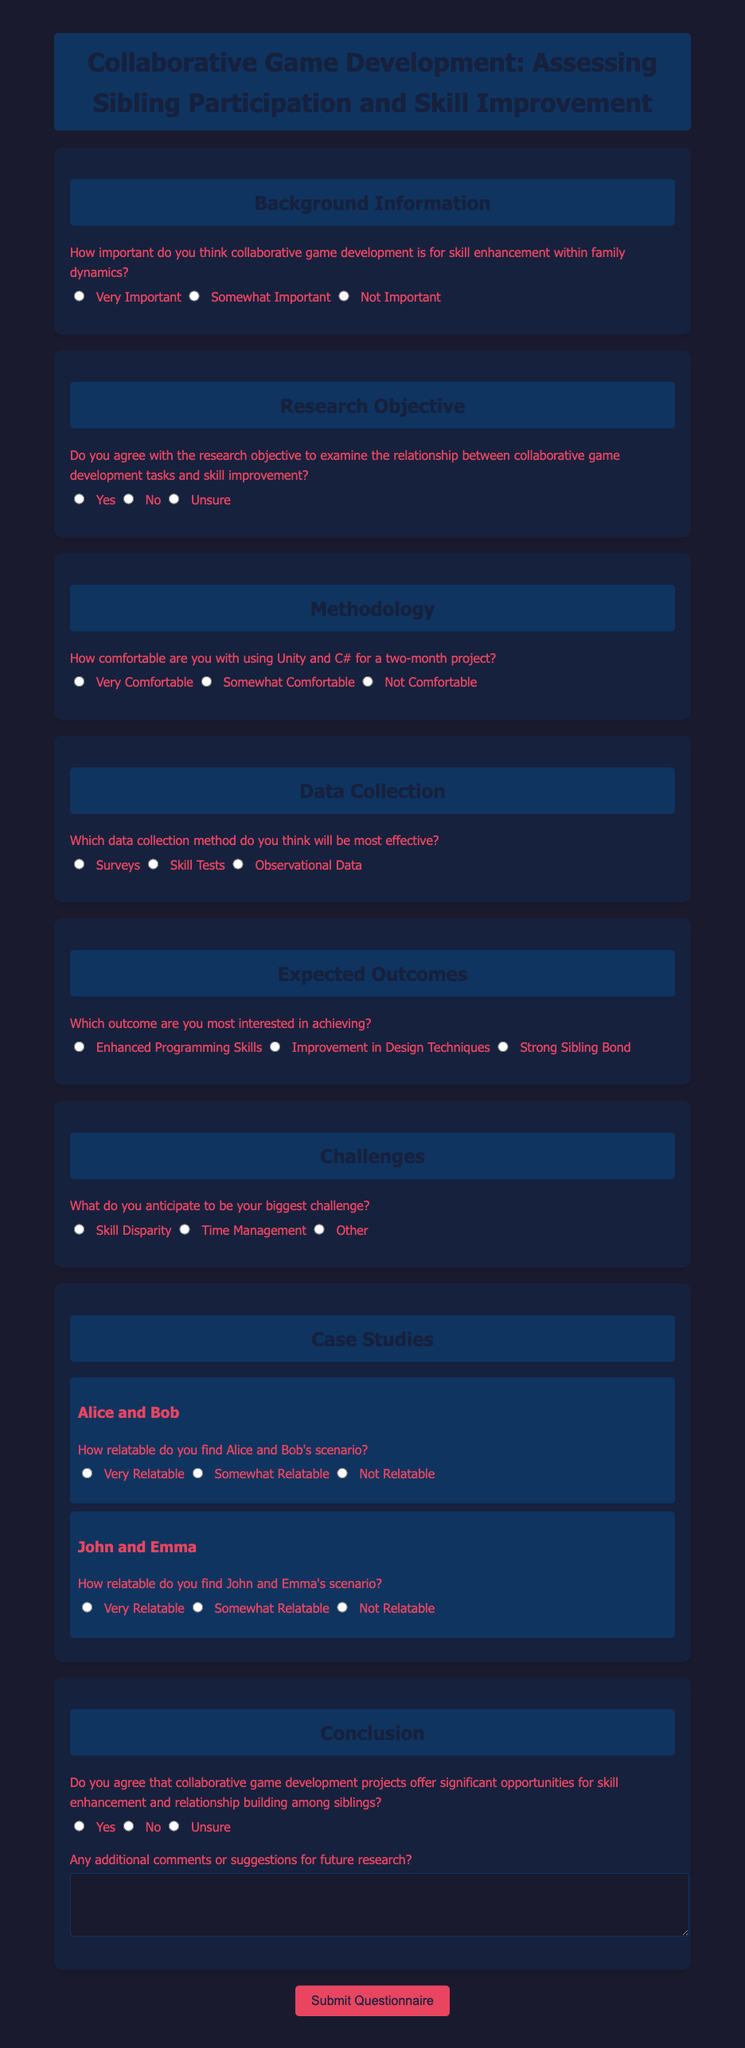What is the title of the questionnaire? The title of the questionnaire is displayed prominently at the top of the document.
Answer: Collaborative Game Development: Assessing Sibling Participation and Skill Improvement What is the background information section focused on? The background information section asks about the importance of collaborative game development for skill enhancement.
Answer: Importance of collaborative game development How many main areas are explored in the document? The document is divided into several sections, each exploring different topics related to collaborative game development.
Answer: Seven Which method is suggested for effective data collection? One of the options provided in the data collection section indicates the preferred method for gathering information.
Answer: Surveys What is the anticipated biggest challenge mentioned in the questionnaire? The questionnaire lists several challenges, and one of the options is to identify the largest anticipated challenge in collaborative projects.
Answer: Skill Disparity How relatable did the respondent find Alice and Bob's scenario? The questionnaire asks for relatability feedback on scenarios, specifically Alice and Bob's situation.
Answer: Very Relatable What are the expected outcomes of collaborative game development according to the document? The questionnaire offers choices regarding which outcomes respondents are interested in achieving through their collaboration.
Answer: Enhanced Programming Skills Is there an additional comments section available in the questionnaire? The conclusion section includes a question about any additional comments or suggestions for further research.
Answer: Yes 